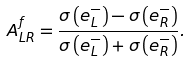<formula> <loc_0><loc_0><loc_500><loc_500>A _ { L R } ^ { f } = \frac { \sigma \left ( e _ { L } ^ { - } \right ) - \sigma \left ( e _ { R } ^ { - } \right ) } { \sigma \left ( e _ { L } ^ { - } \right ) + \sigma \left ( e _ { R } ^ { - } \right ) } .</formula> 